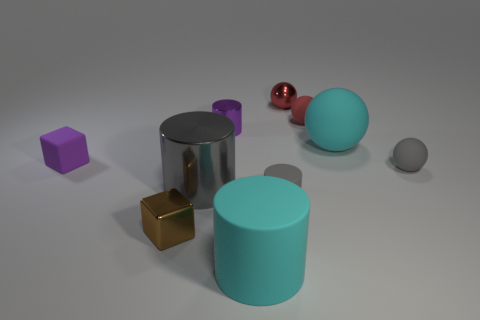Subtract all cubes. How many objects are left? 8 Subtract all large gray metallic cubes. Subtract all gray metal objects. How many objects are left? 9 Add 6 purple matte cubes. How many purple matte cubes are left? 7 Add 7 metallic cubes. How many metallic cubes exist? 8 Subtract 1 cyan cylinders. How many objects are left? 9 